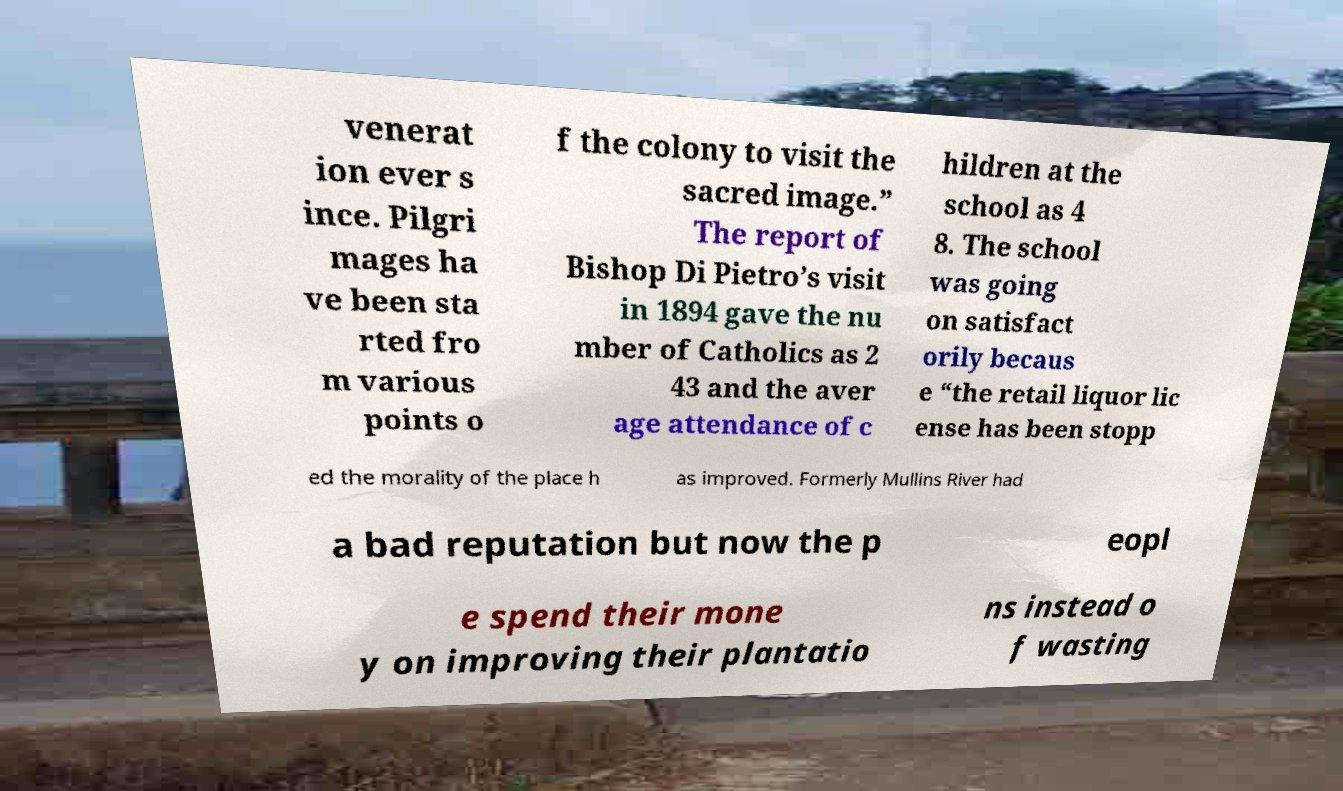There's text embedded in this image that I need extracted. Can you transcribe it verbatim? venerat ion ever s ince. Pilgri mages ha ve been sta rted fro m various points o f the colony to visit the sacred image.” The report of Bishop Di Pietro’s visit in 1894 gave the nu mber of Catholics as 2 43 and the aver age attendance of c hildren at the school as 4 8. The school was going on satisfact orily becaus e “the retail liquor lic ense has been stopp ed the morality of the place h as improved. Formerly Mullins River had a bad reputation but now the p eopl e spend their mone y on improving their plantatio ns instead o f wasting 